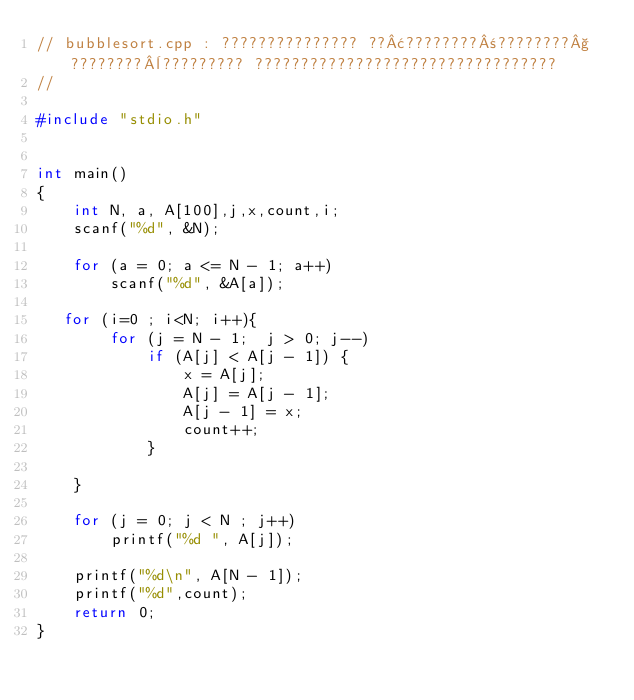<code> <loc_0><loc_0><loc_500><loc_500><_C_>// bubblesort.cpp : ??????????????? ??¢????????±????????§????????¨????????? ?????????????????????????????????
//

#include "stdio.h"


int main()
{
    int N, a, A[100],j,x,count,i;
    scanf("%d", &N);

    for (a = 0; a <= N - 1; a++)
        scanf("%d", &A[a]);

   for (i=0 ; i<N; i++){
        for (j = N - 1;  j > 0; j--) 
            if (A[j] < A[j - 1]) {
                x = A[j];
                A[j] = A[j - 1];
                A[j - 1] = x;
                count++;
            }
         
    }
   
    for (j = 0; j < N ; j++)
        printf("%d ", A[j]);

    printf("%d\n", A[N - 1]);
    printf("%d",count);
    return 0;
}</code> 